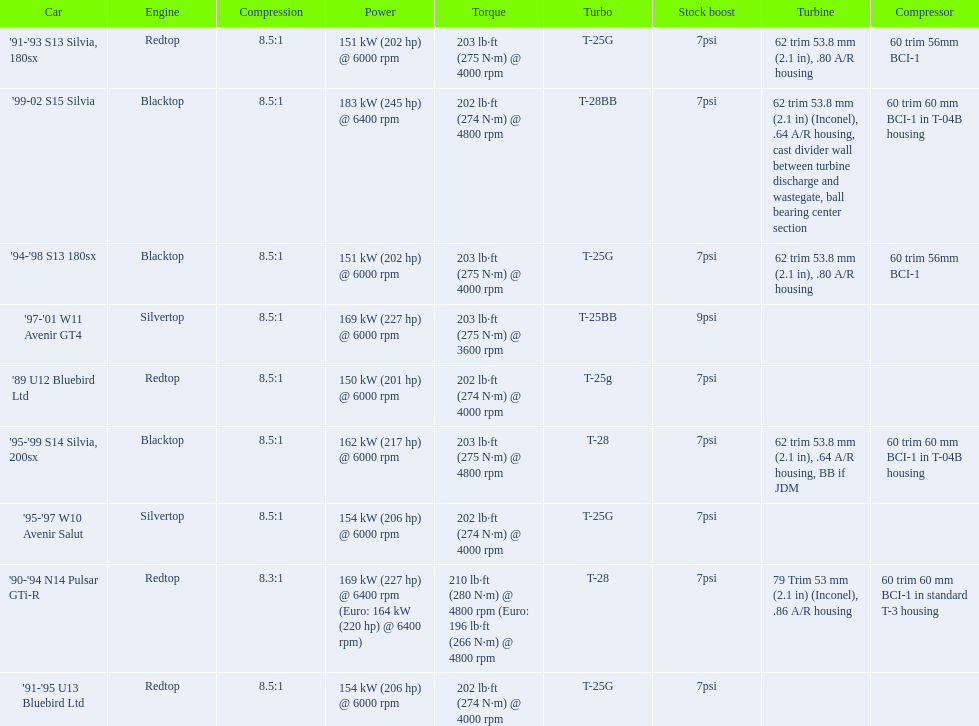What are the psi's? 7psi, 7psi, 7psi, 9psi, 7psi, 7psi, 7psi, 7psi, 7psi. What are the number(s) greater than 7? 9psi. Which car has that number? '97-'01 W11 Avenir GT4. 